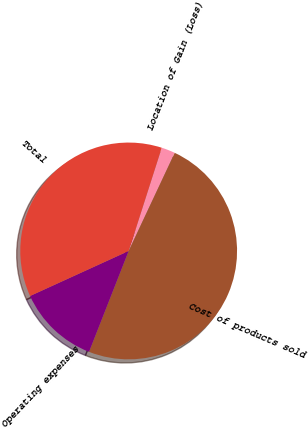Convert chart to OTSL. <chart><loc_0><loc_0><loc_500><loc_500><pie_chart><fcel>Location of Gain (Loss)<fcel>Cost of products sold<fcel>Operating expenses<fcel>Total<nl><fcel>2.05%<fcel>48.97%<fcel>12.23%<fcel>36.75%<nl></chart> 